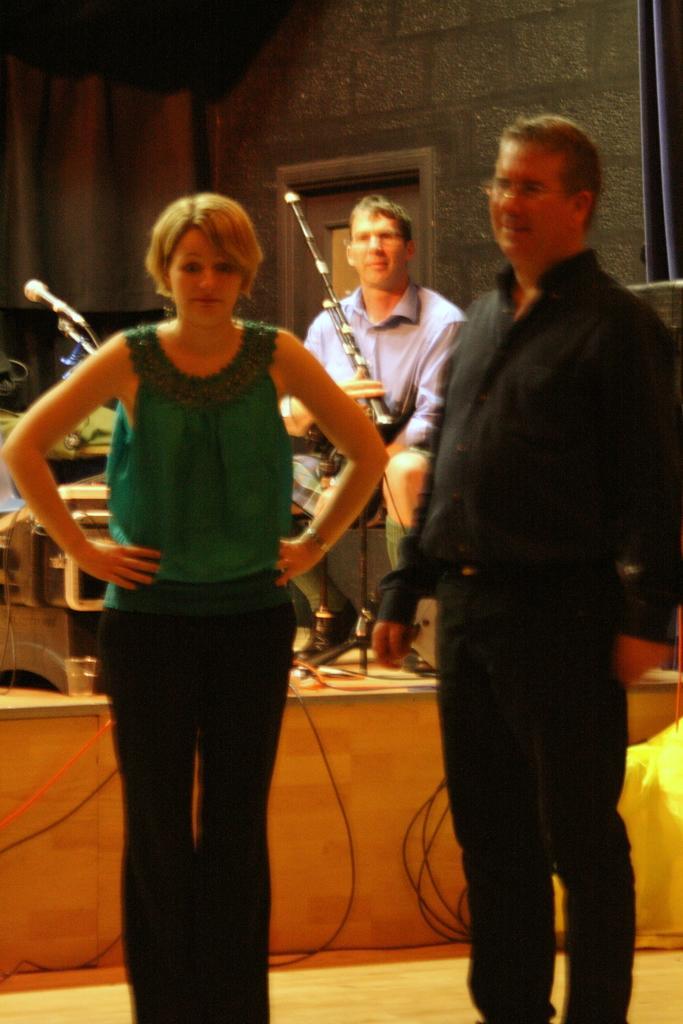Could you give a brief overview of what you see in this image? In this image we can able to see two persons, one of them is man and the other one is women who are standing, behind them another person is sitting on the chair with a musical instrument in his hands, and we can able to see mic in front of him, and there are some wires connect to a machine, we can able to see a wall. 